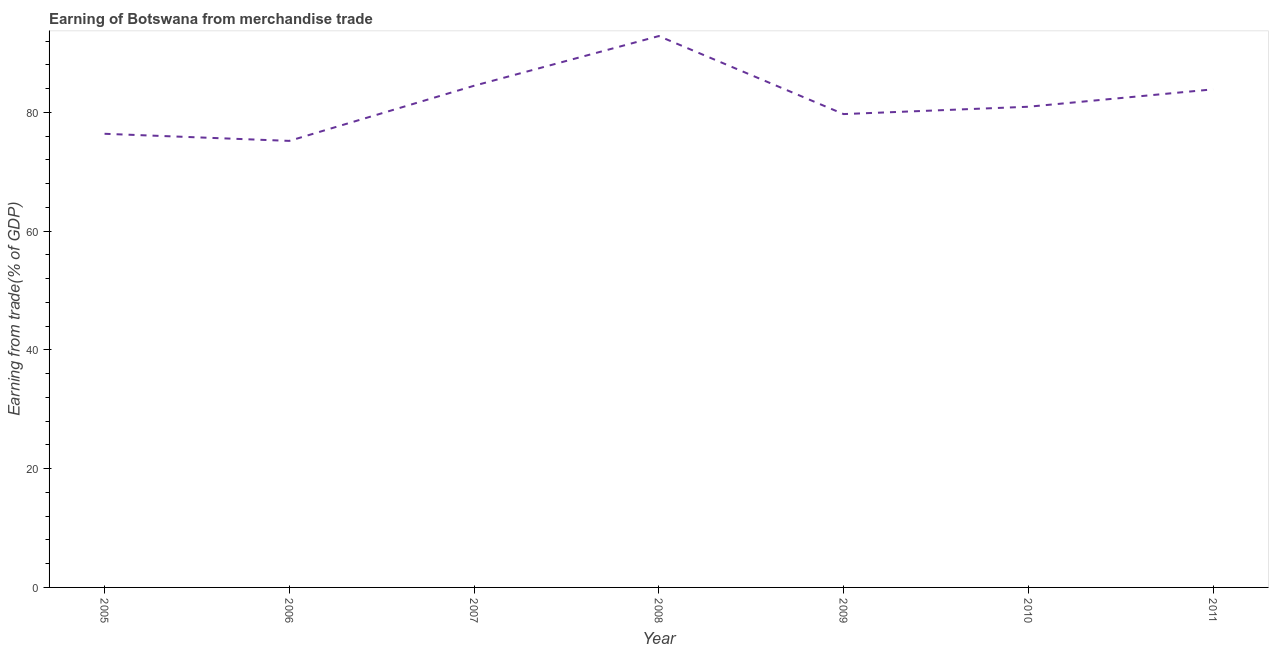What is the earning from merchandise trade in 2010?
Offer a terse response. 80.94. Across all years, what is the maximum earning from merchandise trade?
Give a very brief answer. 92.85. Across all years, what is the minimum earning from merchandise trade?
Give a very brief answer. 75.19. What is the sum of the earning from merchandise trade?
Keep it short and to the point. 573.43. What is the difference between the earning from merchandise trade in 2007 and 2011?
Make the answer very short. 0.61. What is the average earning from merchandise trade per year?
Keep it short and to the point. 81.92. What is the median earning from merchandise trade?
Provide a succinct answer. 80.94. In how many years, is the earning from merchandise trade greater than 88 %?
Give a very brief answer. 1. What is the ratio of the earning from merchandise trade in 2005 to that in 2010?
Give a very brief answer. 0.94. What is the difference between the highest and the second highest earning from merchandise trade?
Your answer should be very brief. 8.37. What is the difference between the highest and the lowest earning from merchandise trade?
Your answer should be very brief. 17.65. In how many years, is the earning from merchandise trade greater than the average earning from merchandise trade taken over all years?
Offer a terse response. 3. Does the earning from merchandise trade monotonically increase over the years?
Provide a short and direct response. No. How many lines are there?
Offer a very short reply. 1. How many years are there in the graph?
Provide a short and direct response. 7. What is the difference between two consecutive major ticks on the Y-axis?
Give a very brief answer. 20. What is the title of the graph?
Offer a terse response. Earning of Botswana from merchandise trade. What is the label or title of the Y-axis?
Provide a short and direct response. Earning from trade(% of GDP). What is the Earning from trade(% of GDP) of 2005?
Offer a very short reply. 76.39. What is the Earning from trade(% of GDP) in 2006?
Offer a terse response. 75.19. What is the Earning from trade(% of GDP) of 2007?
Provide a succinct answer. 84.48. What is the Earning from trade(% of GDP) of 2008?
Ensure brevity in your answer.  92.85. What is the Earning from trade(% of GDP) in 2009?
Provide a short and direct response. 79.71. What is the Earning from trade(% of GDP) in 2010?
Ensure brevity in your answer.  80.94. What is the Earning from trade(% of GDP) of 2011?
Your response must be concise. 83.87. What is the difference between the Earning from trade(% of GDP) in 2005 and 2006?
Keep it short and to the point. 1.2. What is the difference between the Earning from trade(% of GDP) in 2005 and 2007?
Your response must be concise. -8.09. What is the difference between the Earning from trade(% of GDP) in 2005 and 2008?
Provide a succinct answer. -16.46. What is the difference between the Earning from trade(% of GDP) in 2005 and 2009?
Make the answer very short. -3.32. What is the difference between the Earning from trade(% of GDP) in 2005 and 2010?
Offer a very short reply. -4.55. What is the difference between the Earning from trade(% of GDP) in 2005 and 2011?
Offer a very short reply. -7.48. What is the difference between the Earning from trade(% of GDP) in 2006 and 2007?
Ensure brevity in your answer.  -9.29. What is the difference between the Earning from trade(% of GDP) in 2006 and 2008?
Your answer should be very brief. -17.65. What is the difference between the Earning from trade(% of GDP) in 2006 and 2009?
Keep it short and to the point. -4.51. What is the difference between the Earning from trade(% of GDP) in 2006 and 2010?
Ensure brevity in your answer.  -5.75. What is the difference between the Earning from trade(% of GDP) in 2006 and 2011?
Ensure brevity in your answer.  -8.68. What is the difference between the Earning from trade(% of GDP) in 2007 and 2008?
Keep it short and to the point. -8.37. What is the difference between the Earning from trade(% of GDP) in 2007 and 2009?
Offer a terse response. 4.77. What is the difference between the Earning from trade(% of GDP) in 2007 and 2010?
Your answer should be very brief. 3.54. What is the difference between the Earning from trade(% of GDP) in 2007 and 2011?
Your answer should be compact. 0.61. What is the difference between the Earning from trade(% of GDP) in 2008 and 2009?
Ensure brevity in your answer.  13.14. What is the difference between the Earning from trade(% of GDP) in 2008 and 2010?
Provide a short and direct response. 11.9. What is the difference between the Earning from trade(% of GDP) in 2008 and 2011?
Your answer should be compact. 8.97. What is the difference between the Earning from trade(% of GDP) in 2009 and 2010?
Provide a short and direct response. -1.24. What is the difference between the Earning from trade(% of GDP) in 2009 and 2011?
Your response must be concise. -4.17. What is the difference between the Earning from trade(% of GDP) in 2010 and 2011?
Provide a succinct answer. -2.93. What is the ratio of the Earning from trade(% of GDP) in 2005 to that in 2006?
Give a very brief answer. 1.02. What is the ratio of the Earning from trade(% of GDP) in 2005 to that in 2007?
Offer a terse response. 0.9. What is the ratio of the Earning from trade(% of GDP) in 2005 to that in 2008?
Your response must be concise. 0.82. What is the ratio of the Earning from trade(% of GDP) in 2005 to that in 2009?
Ensure brevity in your answer.  0.96. What is the ratio of the Earning from trade(% of GDP) in 2005 to that in 2010?
Offer a terse response. 0.94. What is the ratio of the Earning from trade(% of GDP) in 2005 to that in 2011?
Give a very brief answer. 0.91. What is the ratio of the Earning from trade(% of GDP) in 2006 to that in 2007?
Offer a very short reply. 0.89. What is the ratio of the Earning from trade(% of GDP) in 2006 to that in 2008?
Your answer should be compact. 0.81. What is the ratio of the Earning from trade(% of GDP) in 2006 to that in 2009?
Provide a succinct answer. 0.94. What is the ratio of the Earning from trade(% of GDP) in 2006 to that in 2010?
Provide a succinct answer. 0.93. What is the ratio of the Earning from trade(% of GDP) in 2006 to that in 2011?
Keep it short and to the point. 0.9. What is the ratio of the Earning from trade(% of GDP) in 2007 to that in 2008?
Keep it short and to the point. 0.91. What is the ratio of the Earning from trade(% of GDP) in 2007 to that in 2009?
Your response must be concise. 1.06. What is the ratio of the Earning from trade(% of GDP) in 2007 to that in 2010?
Your answer should be very brief. 1.04. What is the ratio of the Earning from trade(% of GDP) in 2007 to that in 2011?
Ensure brevity in your answer.  1.01. What is the ratio of the Earning from trade(% of GDP) in 2008 to that in 2009?
Provide a short and direct response. 1.17. What is the ratio of the Earning from trade(% of GDP) in 2008 to that in 2010?
Offer a terse response. 1.15. What is the ratio of the Earning from trade(% of GDP) in 2008 to that in 2011?
Keep it short and to the point. 1.11. What is the ratio of the Earning from trade(% of GDP) in 2009 to that in 2010?
Provide a short and direct response. 0.98. 